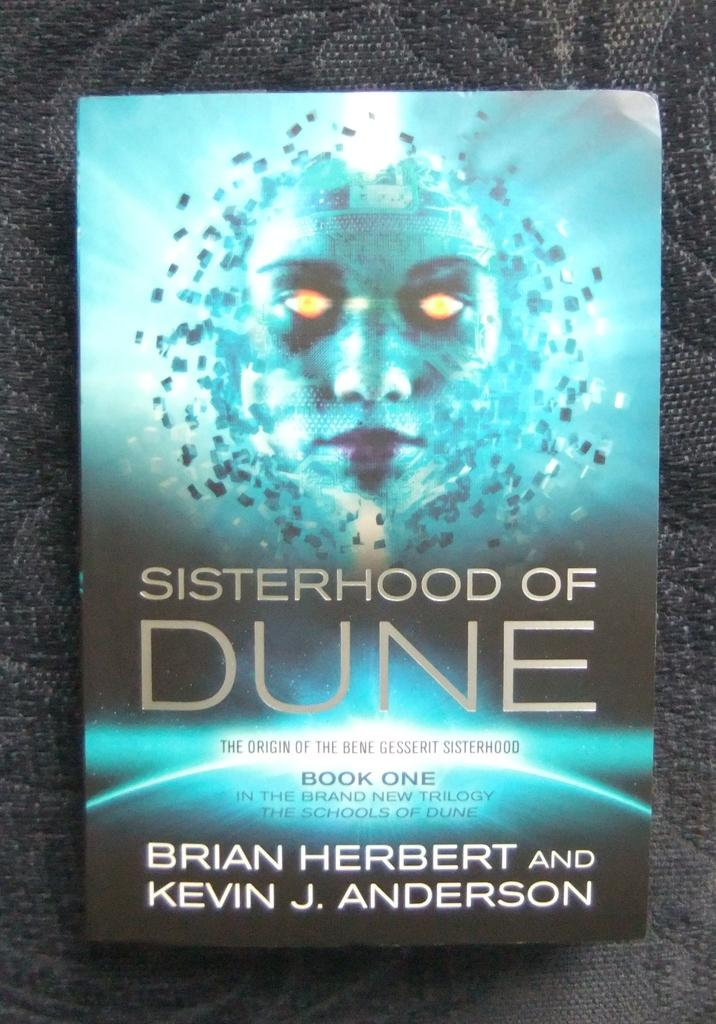<image>
Give a short and clear explanation of the subsequent image. the word Dune is on the book that is blue 